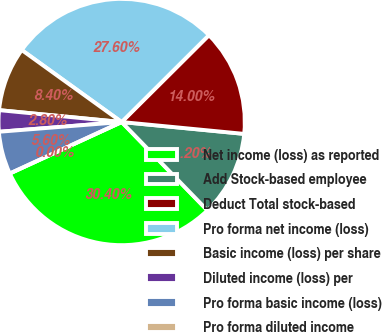<chart> <loc_0><loc_0><loc_500><loc_500><pie_chart><fcel>Net income (loss) as reported<fcel>Add Stock-based employee<fcel>Deduct Total stock-based<fcel>Pro forma net income (loss)<fcel>Basic income (loss) per share<fcel>Diluted income (loss) per<fcel>Pro forma basic income (loss)<fcel>Pro forma diluted income<nl><fcel>30.4%<fcel>11.2%<fcel>14.0%<fcel>27.6%<fcel>8.4%<fcel>2.8%<fcel>5.6%<fcel>0.0%<nl></chart> 